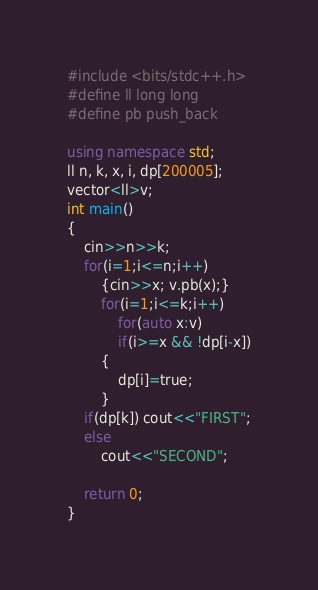Convert code to text. <code><loc_0><loc_0><loc_500><loc_500><_C++_>#include <bits/stdc++.h>
#define ll long long
#define pb push_back

using namespace std;
ll n, k, x, i, dp[200005];
vector<ll>v;
int main()
{
    cin>>n>>k;
    for(i=1;i<=n;i++)
        {cin>>x; v.pb(x);}
        for(i=1;i<=k;i++)
            for(auto x:v)
            if(i>=x && !dp[i-x])
        {
            dp[i]=true;
        }
    if(dp[k]) cout<<"FIRST";
    else
        cout<<"SECOND";

    return 0;
}
</code> 